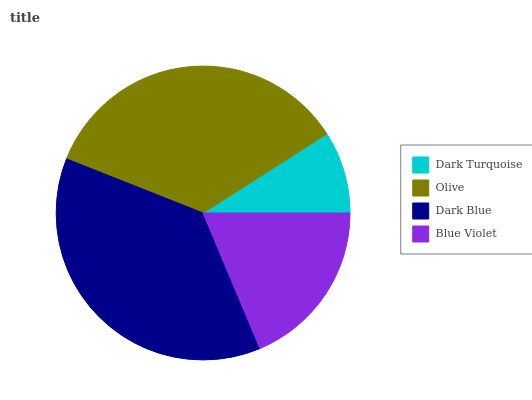Is Dark Turquoise the minimum?
Answer yes or no. Yes. Is Dark Blue the maximum?
Answer yes or no. Yes. Is Olive the minimum?
Answer yes or no. No. Is Olive the maximum?
Answer yes or no. No. Is Olive greater than Dark Turquoise?
Answer yes or no. Yes. Is Dark Turquoise less than Olive?
Answer yes or no. Yes. Is Dark Turquoise greater than Olive?
Answer yes or no. No. Is Olive less than Dark Turquoise?
Answer yes or no. No. Is Olive the high median?
Answer yes or no. Yes. Is Blue Violet the low median?
Answer yes or no. Yes. Is Blue Violet the high median?
Answer yes or no. No. Is Olive the low median?
Answer yes or no. No. 